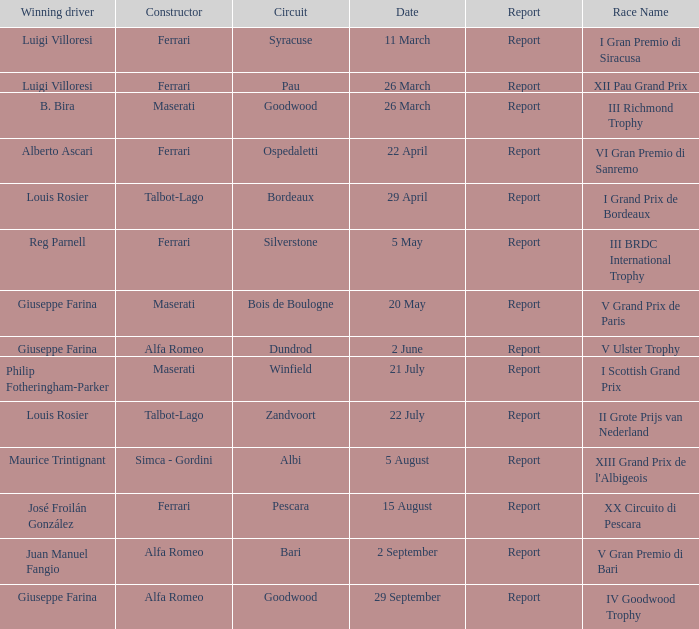Name the report for v grand prix de paris Report. 